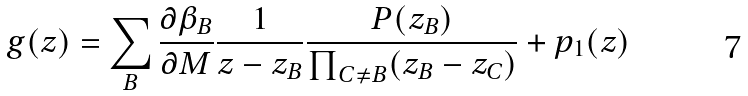Convert formula to latex. <formula><loc_0><loc_0><loc_500><loc_500>g ( z ) = \sum _ { B } \frac { \partial \beta _ { B } } { \partial M } \frac { 1 } { z - z _ { B } } \frac { P ( z _ { B } ) } { \prod _ { C \neq B } ( z _ { B } - z _ { C } ) } + p _ { 1 } ( z )</formula> 